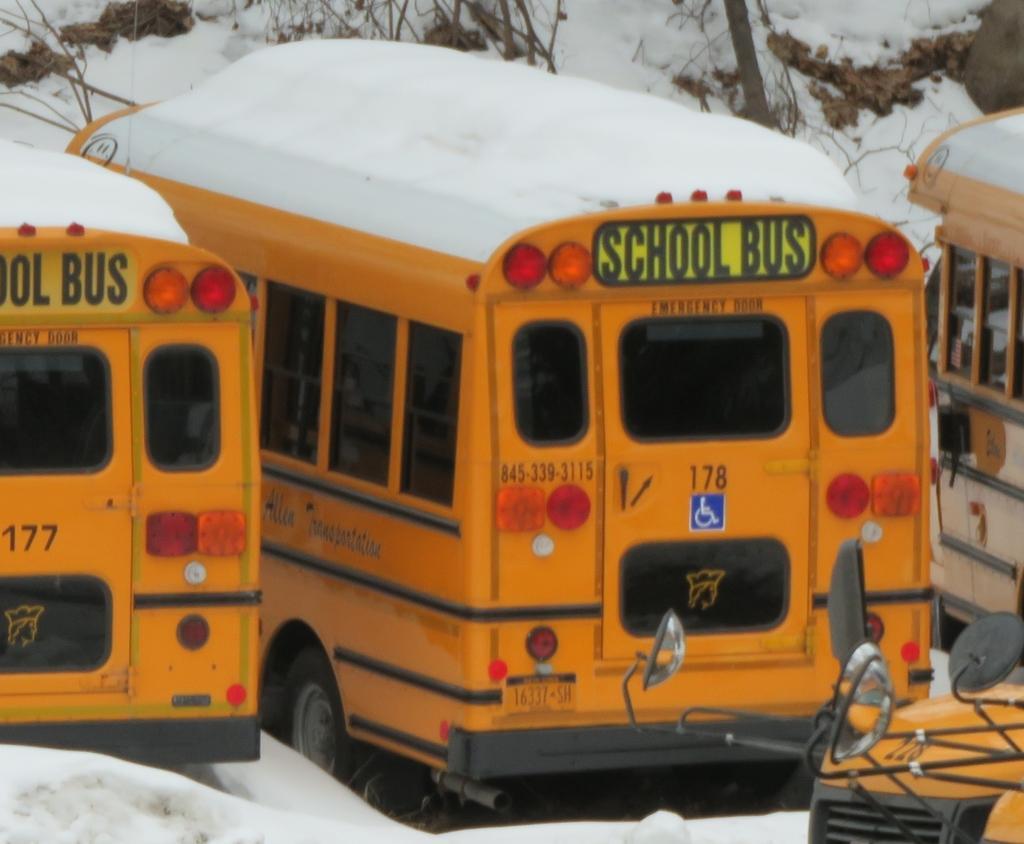Describe this image in one or two sentences. In this image we can see some buses placed on the ground. We can also see the snow. On the backside we can see some branches of the trees. 